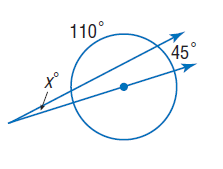Question: Find x. Assume that segments that appear to be tangent are tangent.
Choices:
A. 10
B. 20
C. 45
D. 110
Answer with the letter. Answer: A 